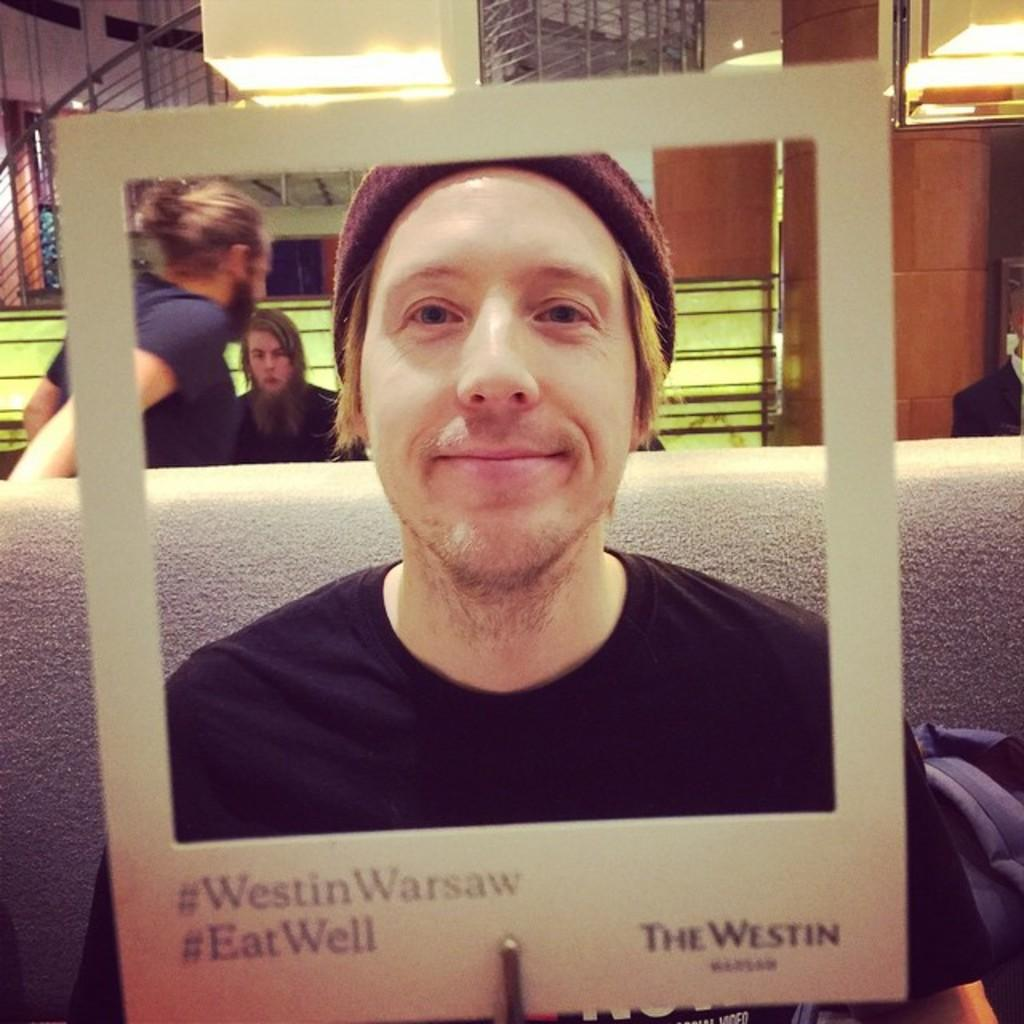What is the person in the image doing? The person is sitting on the sofa in the image. What is located in the foreground of the image? There is a frame in the foreground of the image. What can be seen in the background of the image? There are persons visible in the background of the image, as well as stairs, a light, and a wall. What type of marble is visible in the image? There is no marble present in the image. Can you describe the wilderness visible in the background of the image? There is no wilderness visible in the image; it features a person sitting on a sofa, a frame in the foreground, and various objects and people in the background. 